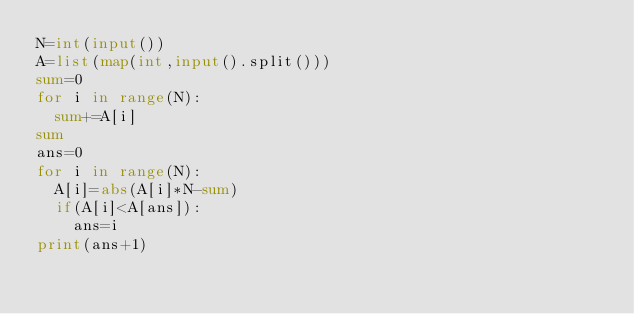Convert code to text. <code><loc_0><loc_0><loc_500><loc_500><_Python_>N=int(input())
A=list(map(int,input().split()))
sum=0
for i in range(N):
  sum+=A[i]
sum
ans=0
for i in range(N):
  A[i]=abs(A[i]*N-sum)
  if(A[i]<A[ans]):
    ans=i
print(ans+1)</code> 